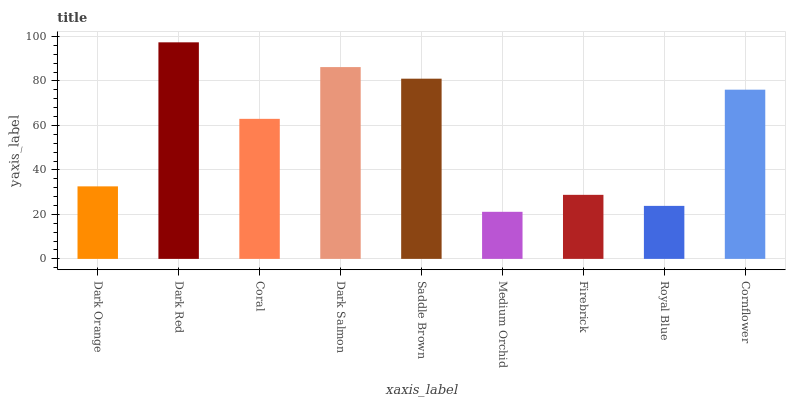Is Medium Orchid the minimum?
Answer yes or no. Yes. Is Dark Red the maximum?
Answer yes or no. Yes. Is Coral the minimum?
Answer yes or no. No. Is Coral the maximum?
Answer yes or no. No. Is Dark Red greater than Coral?
Answer yes or no. Yes. Is Coral less than Dark Red?
Answer yes or no. Yes. Is Coral greater than Dark Red?
Answer yes or no. No. Is Dark Red less than Coral?
Answer yes or no. No. Is Coral the high median?
Answer yes or no. Yes. Is Coral the low median?
Answer yes or no. Yes. Is Cornflower the high median?
Answer yes or no. No. Is Royal Blue the low median?
Answer yes or no. No. 